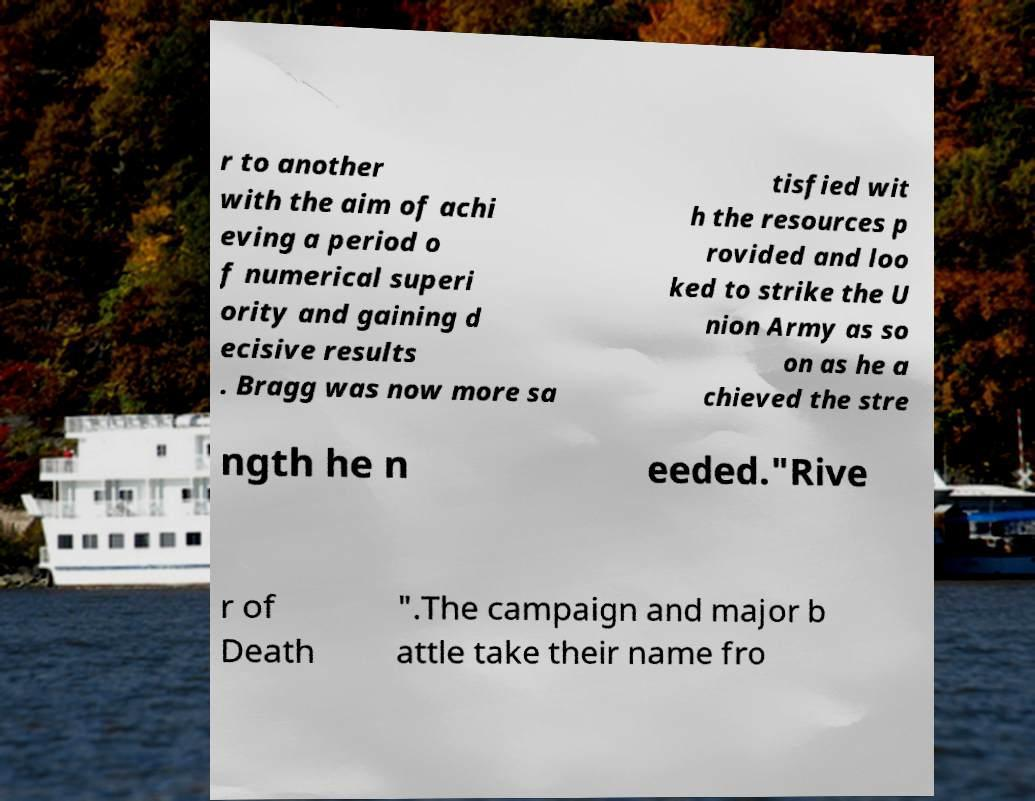I need the written content from this picture converted into text. Can you do that? r to another with the aim of achi eving a period o f numerical superi ority and gaining d ecisive results . Bragg was now more sa tisfied wit h the resources p rovided and loo ked to strike the U nion Army as so on as he a chieved the stre ngth he n eeded."Rive r of Death ".The campaign and major b attle take their name fro 